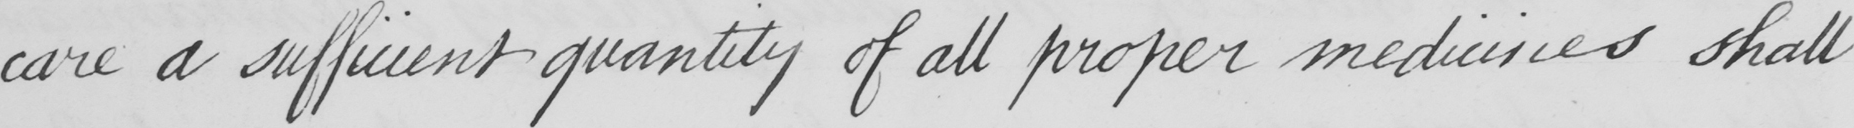Please provide the text content of this handwritten line. care a sufficient quantity of all proper medicines shall 